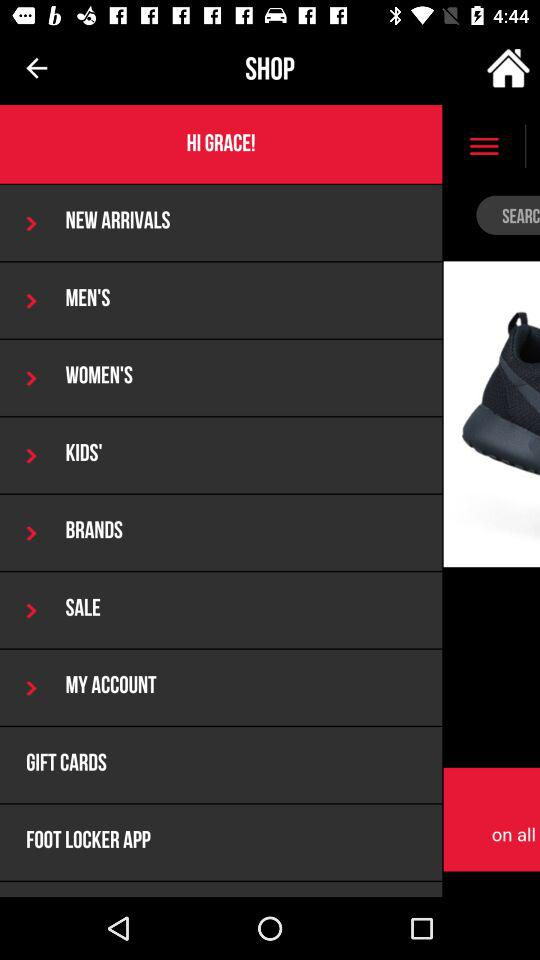What is the selected date? The selected date is Tuesday, 6 December 2016. 